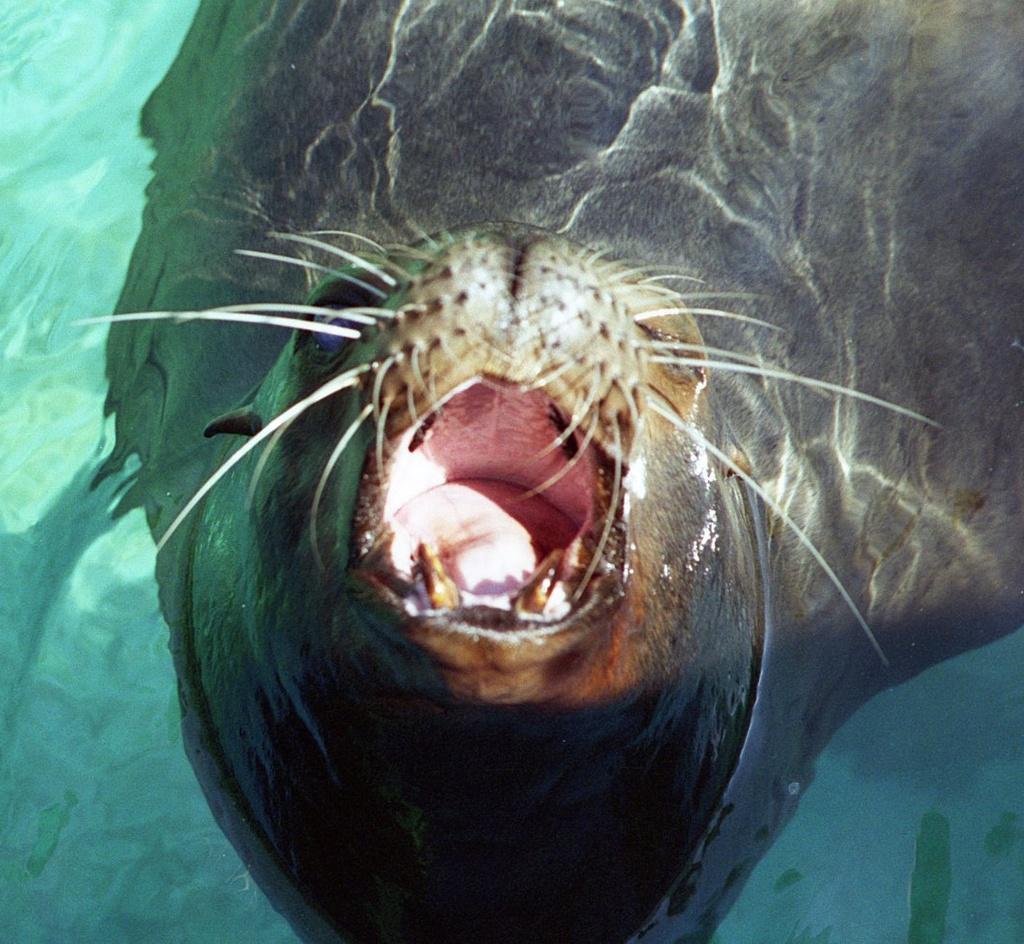Please provide a concise description of this image. In this image there is a seal in the water. 